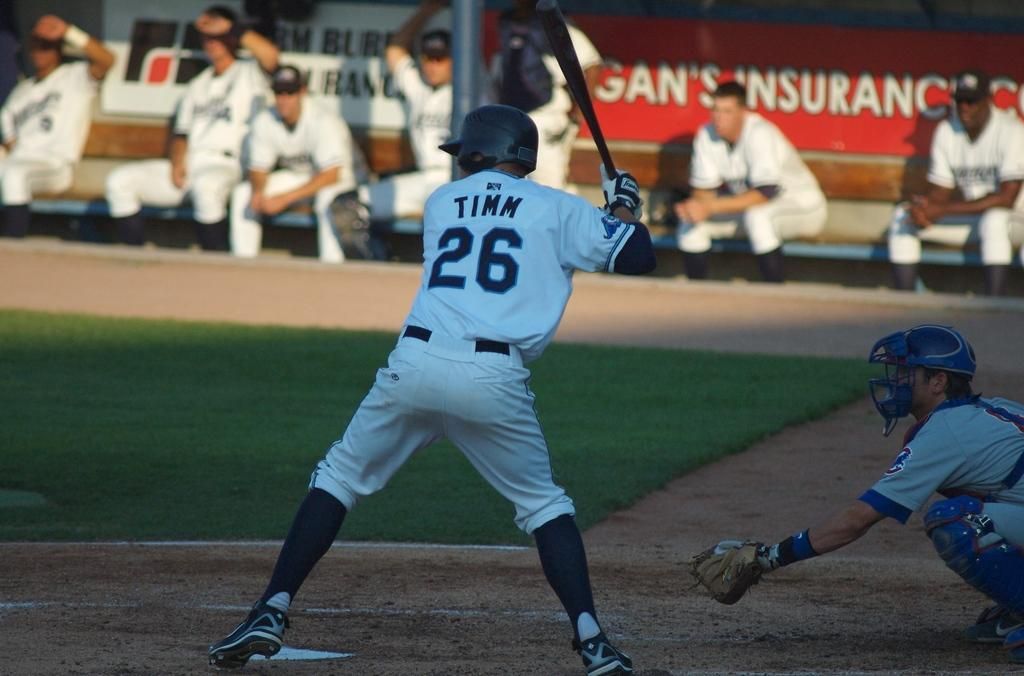<image>
Relay a brief, clear account of the picture shown. The player up to bat is Timm, number 26. 